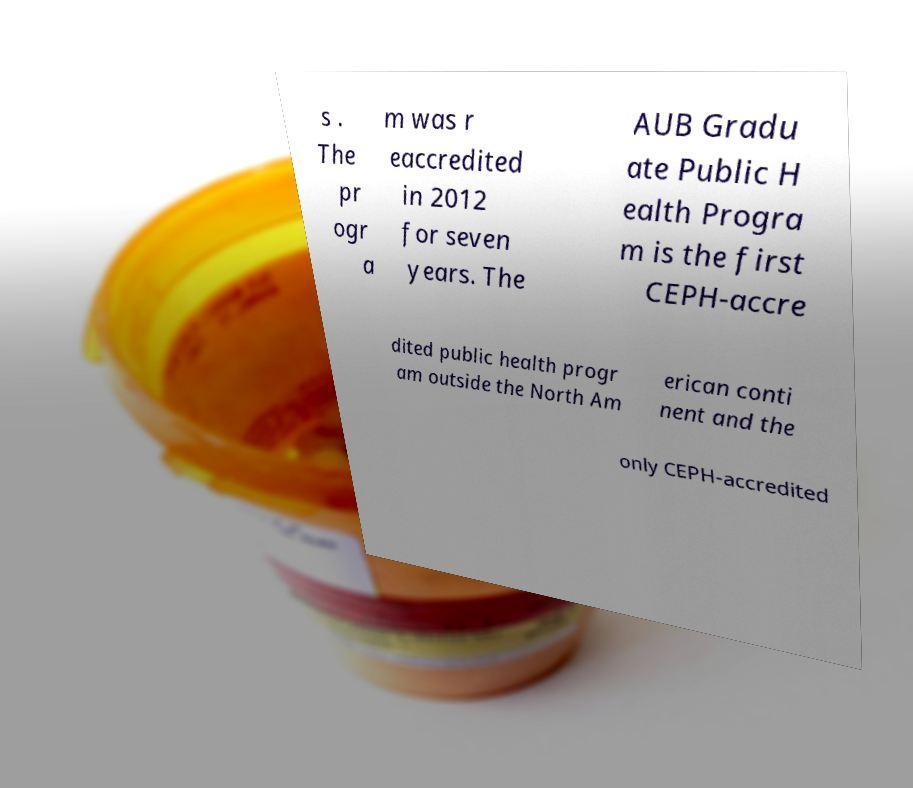Could you assist in decoding the text presented in this image and type it out clearly? s . The pr ogr a m was r eaccredited in 2012 for seven years. The AUB Gradu ate Public H ealth Progra m is the first CEPH-accre dited public health progr am outside the North Am erican conti nent and the only CEPH-accredited 